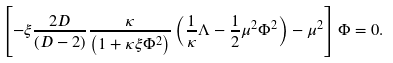Convert formula to latex. <formula><loc_0><loc_0><loc_500><loc_500>\left [ - \xi \frac { 2 D } { \left ( D - 2 \right ) } \frac { \kappa } { \left ( 1 + \kappa \xi \Phi ^ { 2 } \right ) } \left ( \frac { 1 } { \kappa } \Lambda - \frac { 1 } { 2 } \mu ^ { 2 } \Phi ^ { 2 } \right ) - \mu ^ { 2 } \right ] \Phi = 0 .</formula> 